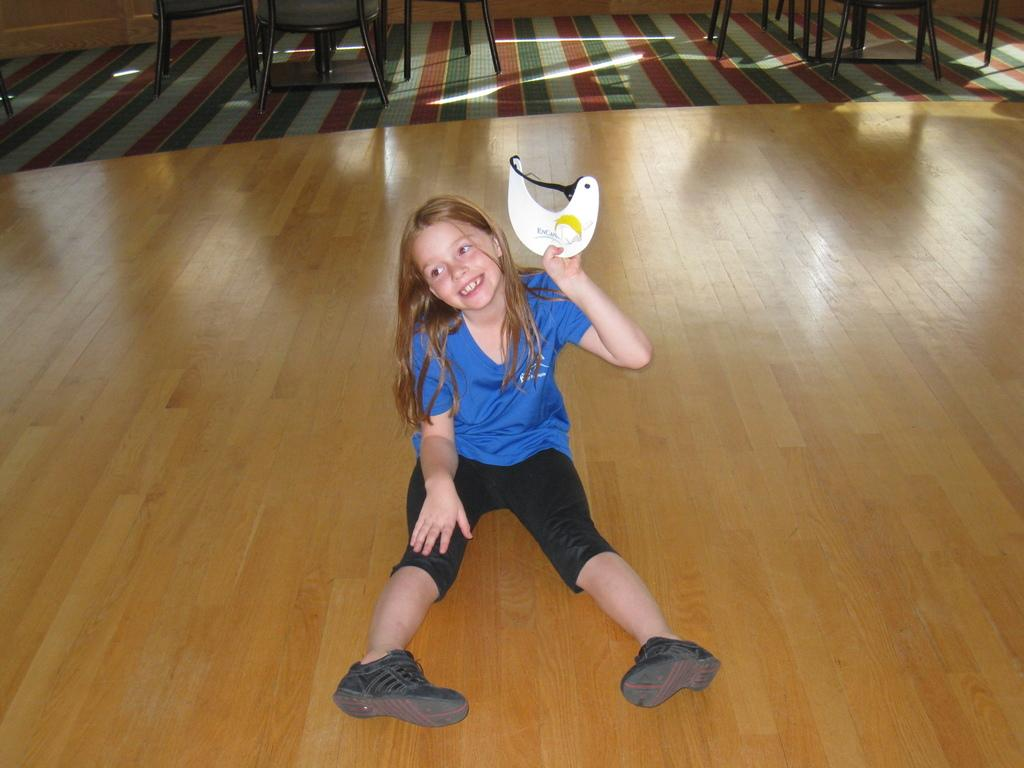Who is the main subject in the image? There is a girl in the image. What is the girl doing in the image? The girl is sitting on the floor and smiling. What is the girl holding in her hand? The girl is holding something in her hand, but we cannot determine what it is from the image. What can be seen in the background of the image? There are chairs and other objects on the floor in the background of the image. What type of map is the girl using to get out of trouble in the image? There is no map or trouble present in the image; it simply shows a girl sitting on the floor and smiling. 